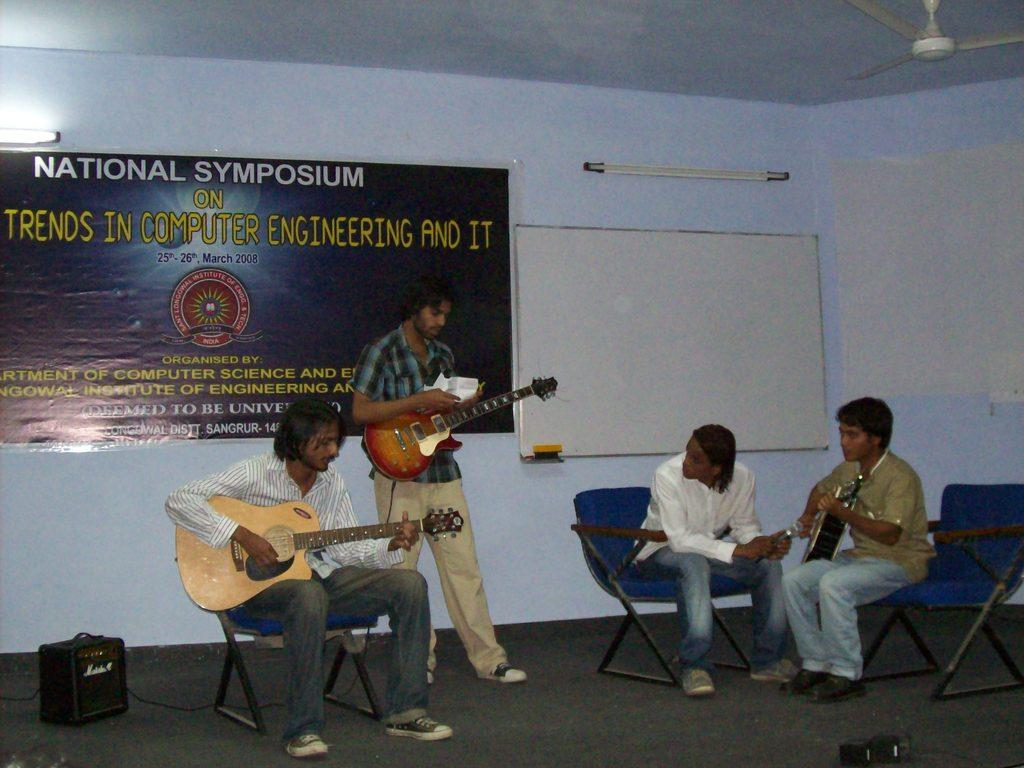How many people are performing on the stage in the image? There are 4 people on the stage. What are the people doing on the stage? The people are performing by playing musical instruments. What can be seen behind the performers on the stage? There is a wallboard, a banner, a fan, and a light behind them. What type of finger is visible on the wallboard behind the performers? There are no fingers visible on the wallboard behind the performers; it is a flat surface. 